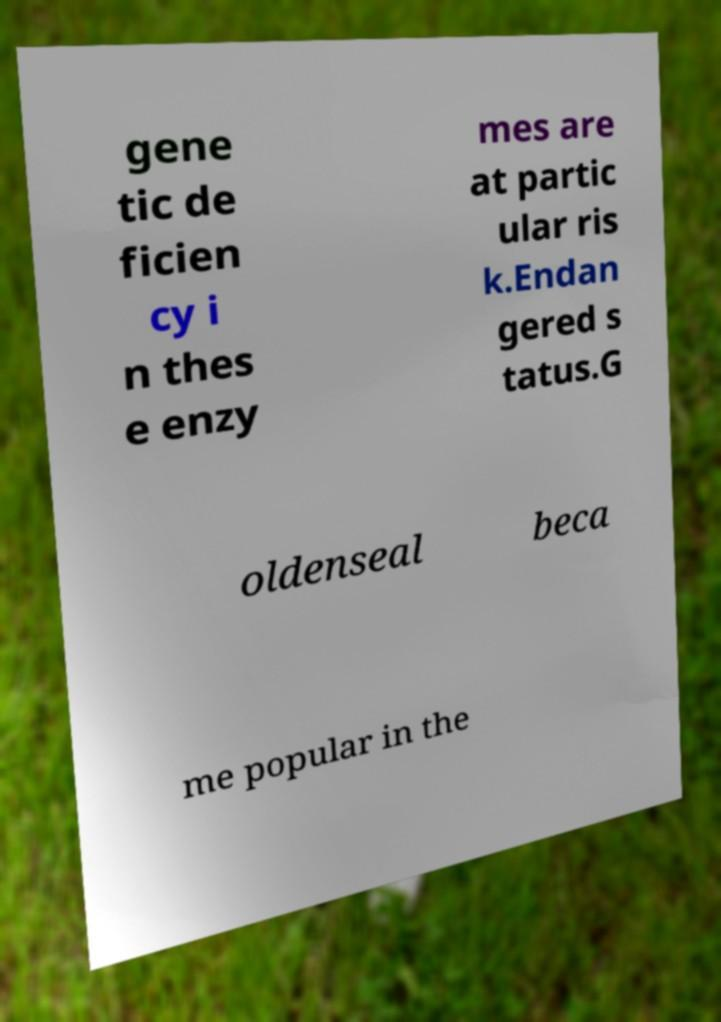What messages or text are displayed in this image? I need them in a readable, typed format. gene tic de ficien cy i n thes e enzy mes are at partic ular ris k.Endan gered s tatus.G oldenseal beca me popular in the 